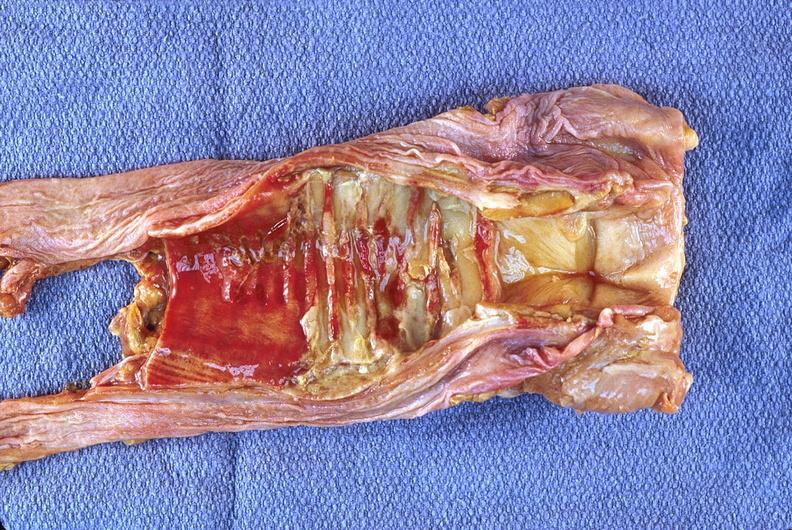what is present?
Answer the question using a single word or phrase. Respiratory 